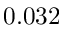<formula> <loc_0><loc_0><loc_500><loc_500>0 . 0 3 2</formula> 